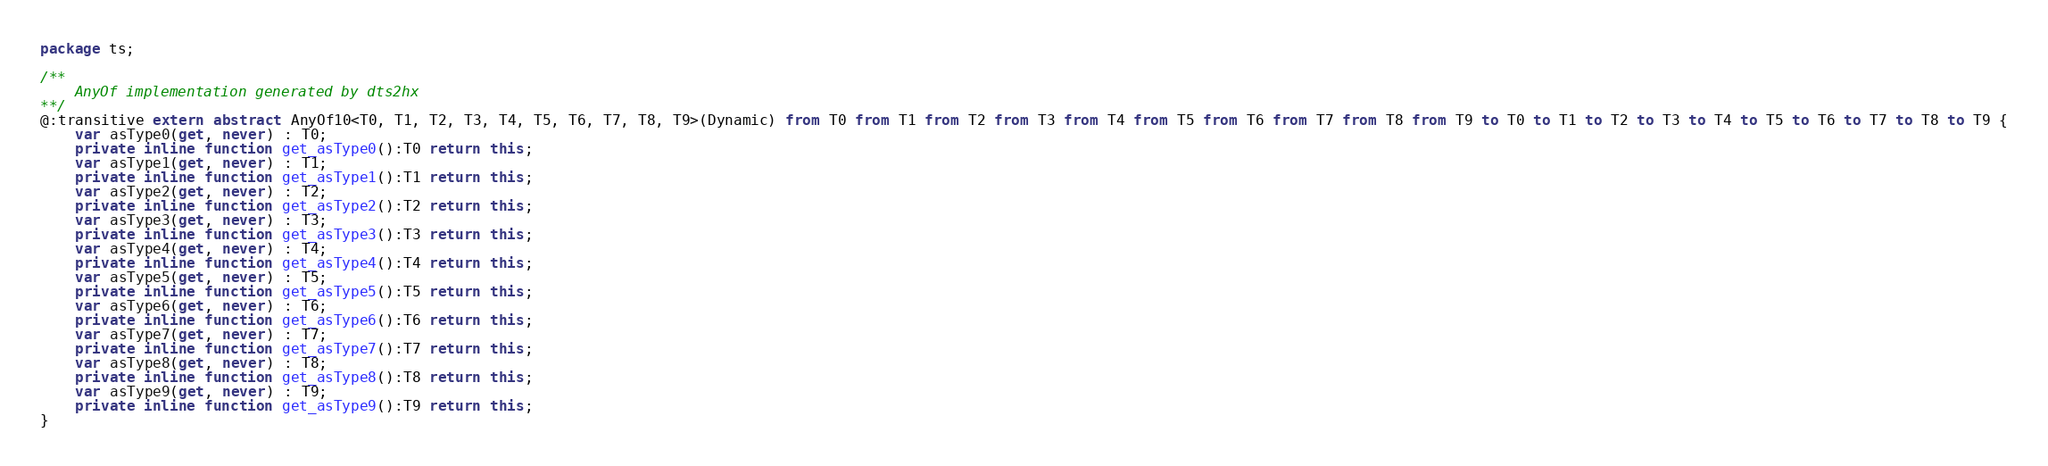Convert code to text. <code><loc_0><loc_0><loc_500><loc_500><_Haxe_>package ts;

/**
	AnyOf implementation generated by dts2hx
**/
@:transitive extern abstract AnyOf10<T0, T1, T2, T3, T4, T5, T6, T7, T8, T9>(Dynamic) from T0 from T1 from T2 from T3 from T4 from T5 from T6 from T7 from T8 from T9 to T0 to T1 to T2 to T3 to T4 to T5 to T6 to T7 to T8 to T9 {
	var asType0(get, never) : T0;
	private inline function get_asType0():T0 return this;
	var asType1(get, never) : T1;
	private inline function get_asType1():T1 return this;
	var asType2(get, never) : T2;
	private inline function get_asType2():T2 return this;
	var asType3(get, never) : T3;
	private inline function get_asType3():T3 return this;
	var asType4(get, never) : T4;
	private inline function get_asType4():T4 return this;
	var asType5(get, never) : T5;
	private inline function get_asType5():T5 return this;
	var asType6(get, never) : T6;
	private inline function get_asType6():T6 return this;
	var asType7(get, never) : T7;
	private inline function get_asType7():T7 return this;
	var asType8(get, never) : T8;
	private inline function get_asType8():T8 return this;
	var asType9(get, never) : T9;
	private inline function get_asType9():T9 return this;
}</code> 